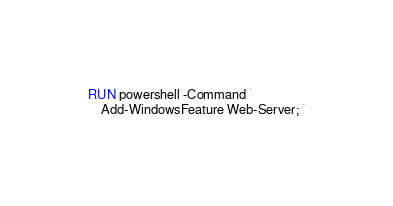Convert code to text. <code><loc_0><loc_0><loc_500><loc_500><_Dockerfile_>RUN powershell -Command `
    Add-WindowsFeature Web-Server; `</code> 